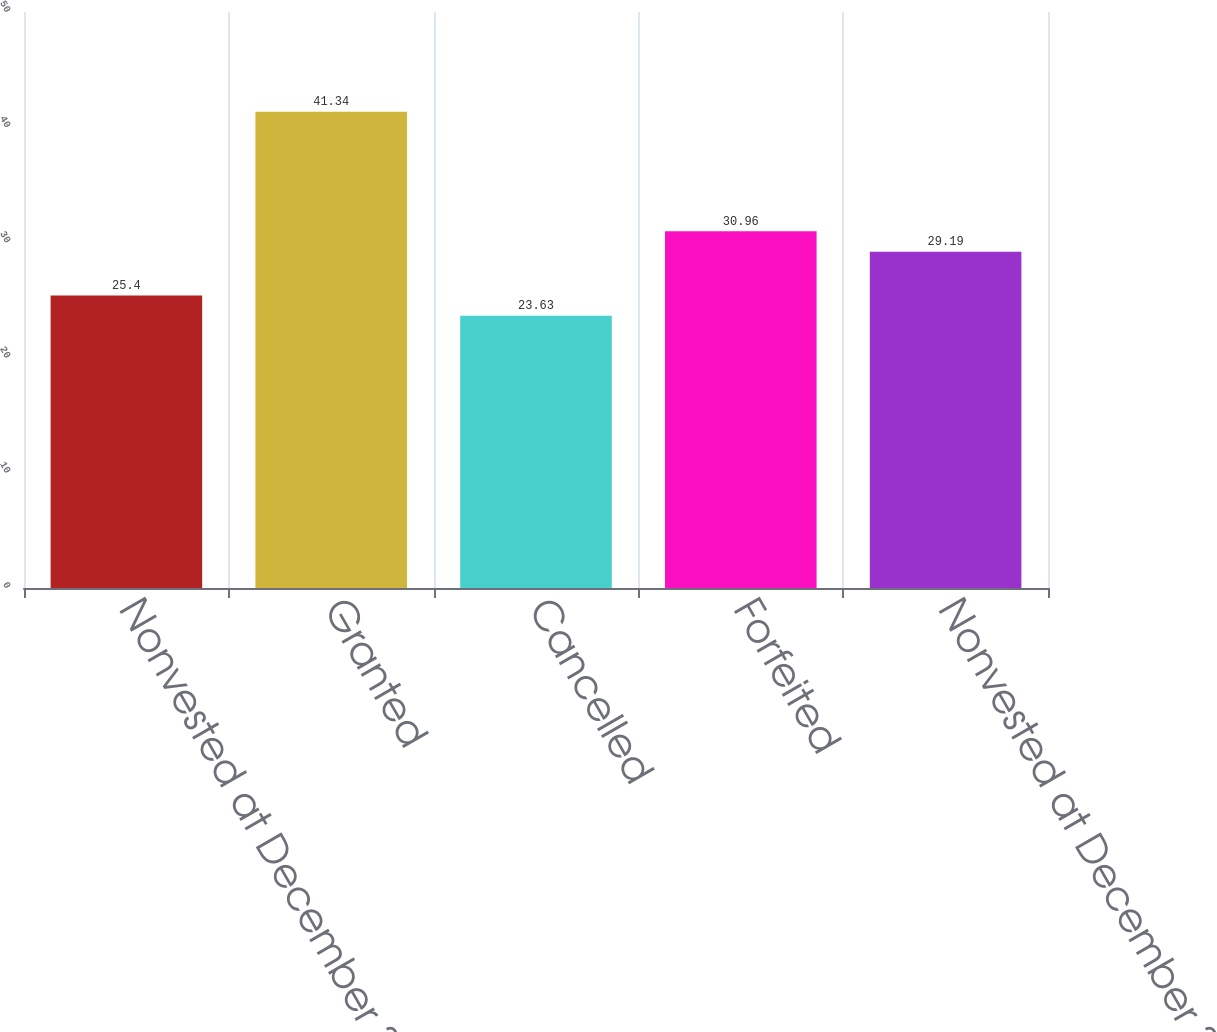Convert chart. <chart><loc_0><loc_0><loc_500><loc_500><bar_chart><fcel>Nonvested at December 31 2009<fcel>Granted<fcel>Cancelled<fcel>Forfeited<fcel>Nonvested at December 31 2010<nl><fcel>25.4<fcel>41.34<fcel>23.63<fcel>30.96<fcel>29.19<nl></chart> 